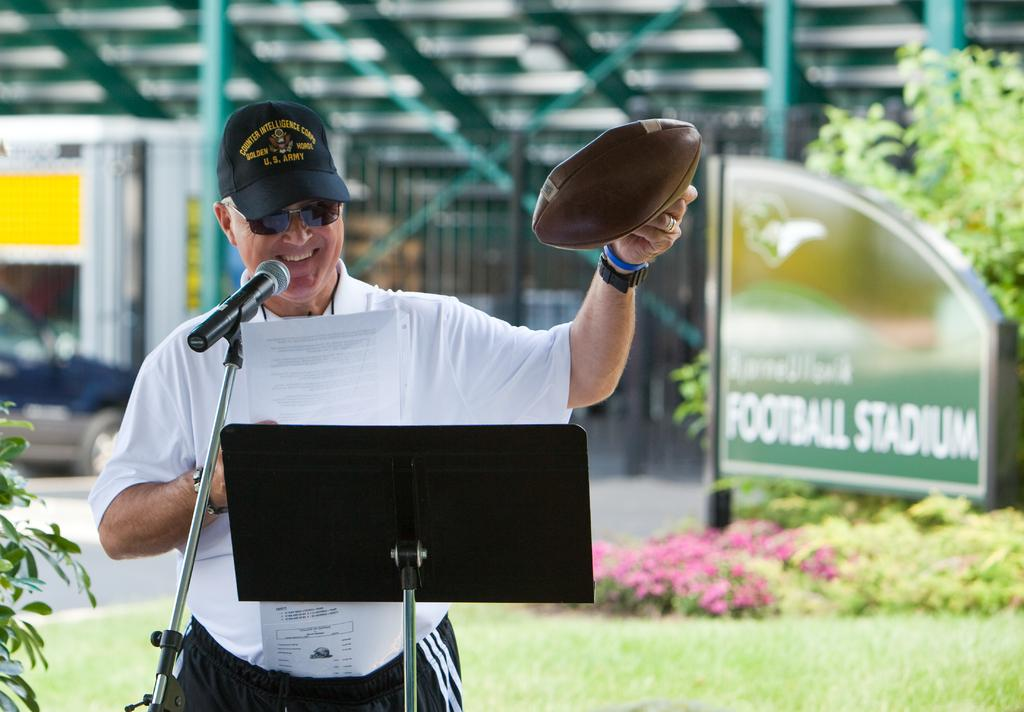What is the man in the image doing near the microphone? The man is standing near a microphone in the image. What can be seen on the right side of the image? There are flowers on the right side of the image. What type of ground surface is visible in the image? There is grass visible in the image. What is written on the board in the image? There is a board with text written on it in the image. What type of haircut does the man have in the image? The image does not show the man's haircut, as it only shows him standing near a microphone. What time of day is it in the image, considering the presence of night? The image does not depict night; it is daytime, as indicated by the visible grass and flowers. 